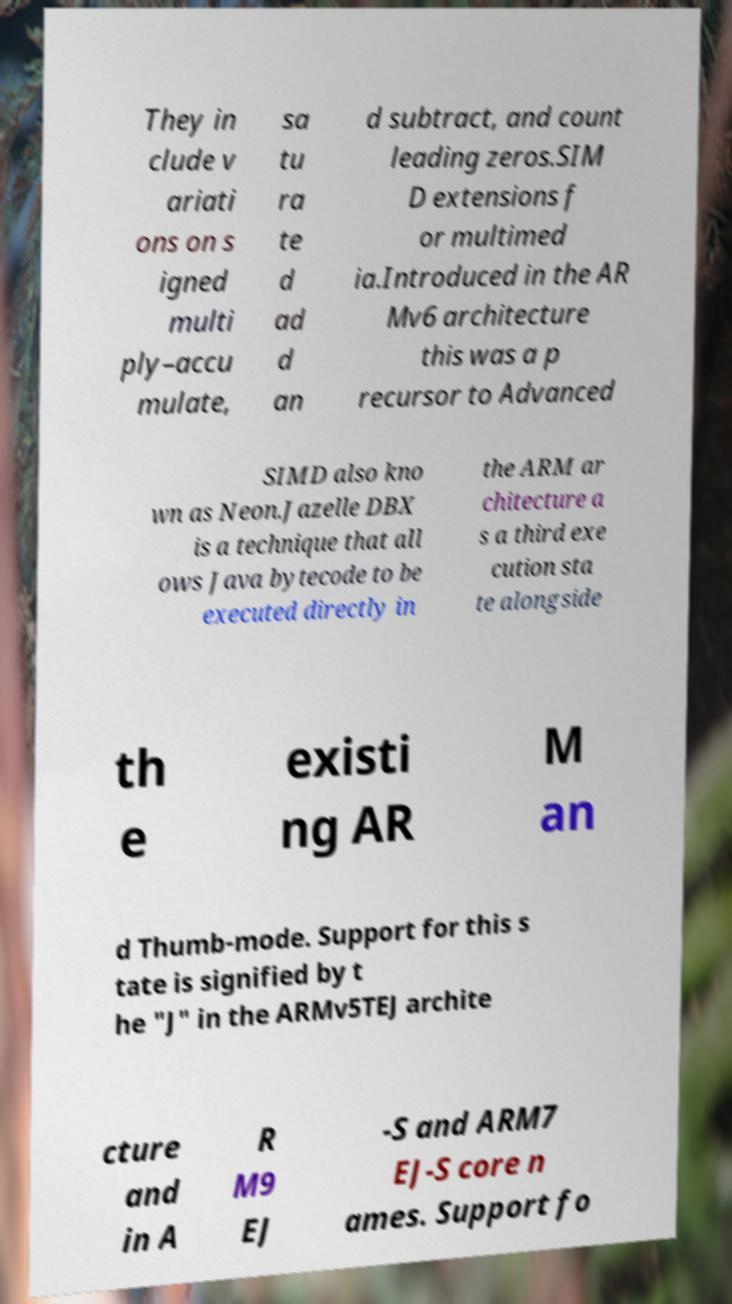Can you accurately transcribe the text from the provided image for me? They in clude v ariati ons on s igned multi ply–accu mulate, sa tu ra te d ad d an d subtract, and count leading zeros.SIM D extensions f or multimed ia.Introduced in the AR Mv6 architecture this was a p recursor to Advanced SIMD also kno wn as Neon.Jazelle DBX is a technique that all ows Java bytecode to be executed directly in the ARM ar chitecture a s a third exe cution sta te alongside th e existi ng AR M an d Thumb-mode. Support for this s tate is signified by t he "J" in the ARMv5TEJ archite cture and in A R M9 EJ -S and ARM7 EJ-S core n ames. Support fo 